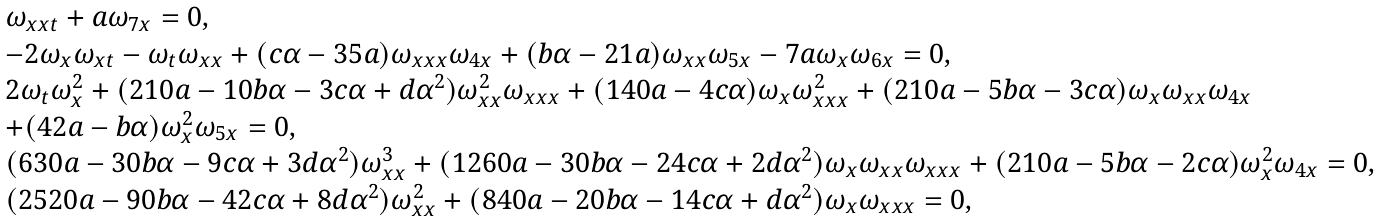<formula> <loc_0><loc_0><loc_500><loc_500>\begin{array} { l } \omega _ { x x t } + a \omega _ { 7 x } = 0 , \\ - 2 \omega _ { x } \omega _ { x t } - \omega _ { t } \omega _ { x x } + ( c \alpha - 3 5 a ) \omega _ { x x x } \omega _ { 4 x } + ( b \alpha - 2 1 a ) \omega _ { x x } \omega _ { 5 x } - 7 a \omega _ { x } \omega _ { 6 x } = 0 , \\ 2 \omega _ { t } \omega _ { x } ^ { 2 } + ( 2 1 0 a - 1 0 b \alpha - 3 c \alpha + d \alpha ^ { 2 } ) \omega _ { x x } ^ { 2 } \omega _ { x x x } + ( 1 4 0 a - 4 c \alpha ) \omega _ { x } \omega _ { x x x } ^ { 2 } + ( 2 1 0 a - 5 b \alpha - 3 c \alpha ) \omega _ { x } \omega _ { x x } \omega _ { 4 x } \\ + ( 4 2 a - b \alpha ) \omega _ { x } ^ { 2 } \omega _ { 5 x } = 0 , \\ ( 6 3 0 a - 3 0 b \alpha - 9 c \alpha + 3 d \alpha ^ { 2 } ) \omega _ { x x } ^ { 3 } + ( 1 2 6 0 a - 3 0 b \alpha - 2 4 c \alpha + 2 d \alpha ^ { 2 } ) \omega _ { x } \omega _ { x x } \omega _ { x x x } + ( 2 1 0 a - 5 b \alpha - 2 c \alpha ) \omega _ { x } ^ { 2 } \omega _ { 4 x } = 0 , \\ ( 2 5 2 0 a - 9 0 b \alpha - 4 2 c \alpha + 8 d \alpha ^ { 2 } ) \omega _ { x x } ^ { 2 } + ( 8 4 0 a - 2 0 b \alpha - 1 4 c \alpha + d \alpha ^ { 2 } ) \omega _ { x } \omega _ { x x x } = 0 , \end{array}</formula> 